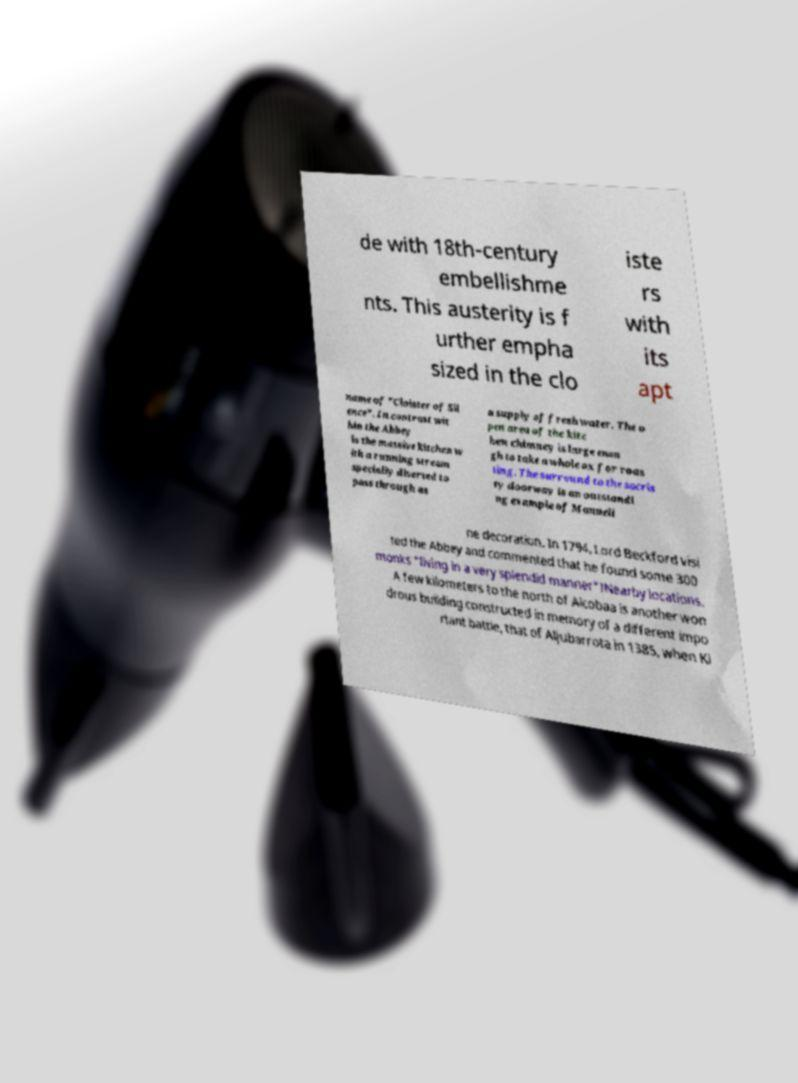For documentation purposes, I need the text within this image transcribed. Could you provide that? de with 18th-century embellishme nts. This austerity is f urther empha sized in the clo iste rs with its apt name of "Cloister of Sil ence". In contrast wit hin the Abbey is the massive kitchen w ith a running stream specially diverted to pass through as a supply of fresh water. The o pen area of the kitc hen chimney is large enou gh to take a whole ox for roas ting. The surround to the sacris ty doorway is an outstandi ng example of Manueli ne decoration. In 1794, Lord Beckford visi ted the Abbey and commented that he found some 300 monks "living in a very splendid manner"!Nearby locations. A few kilometers to the north of Alcobaa is another won drous building constructed in memory of a different impo rtant battle, that of Aljubarrota in 1385, when Ki 